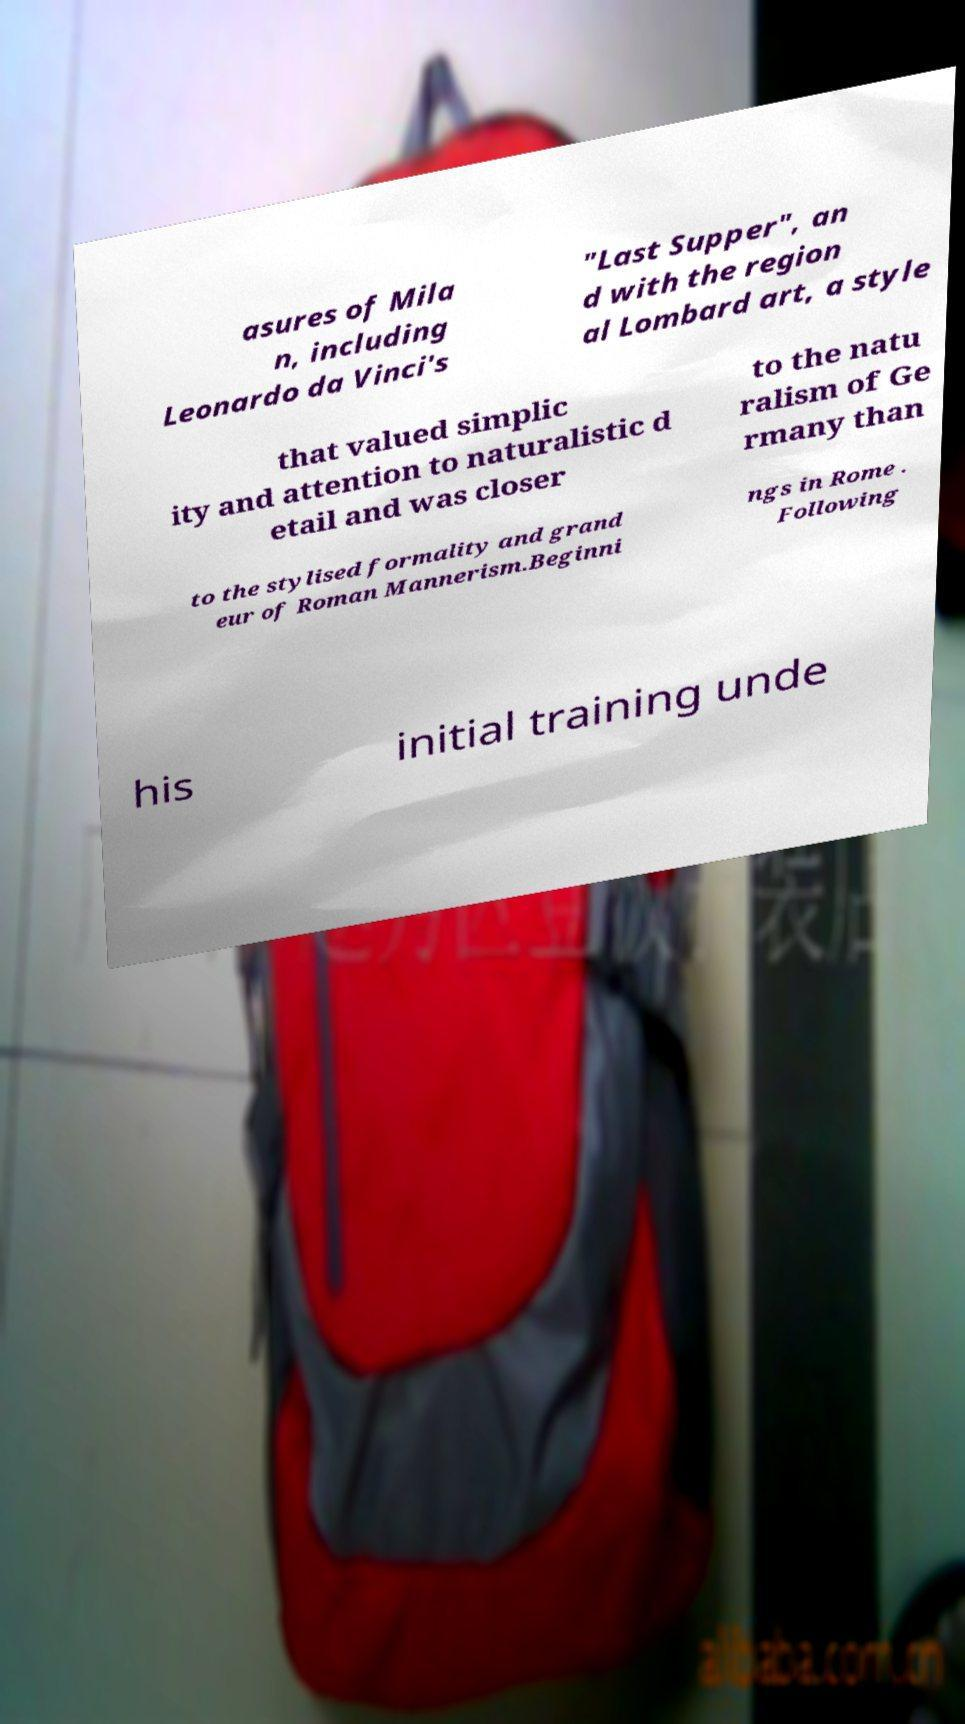Could you extract and type out the text from this image? asures of Mila n, including Leonardo da Vinci's "Last Supper", an d with the region al Lombard art, a style that valued simplic ity and attention to naturalistic d etail and was closer to the natu ralism of Ge rmany than to the stylised formality and grand eur of Roman Mannerism.Beginni ngs in Rome . Following his initial training unde 